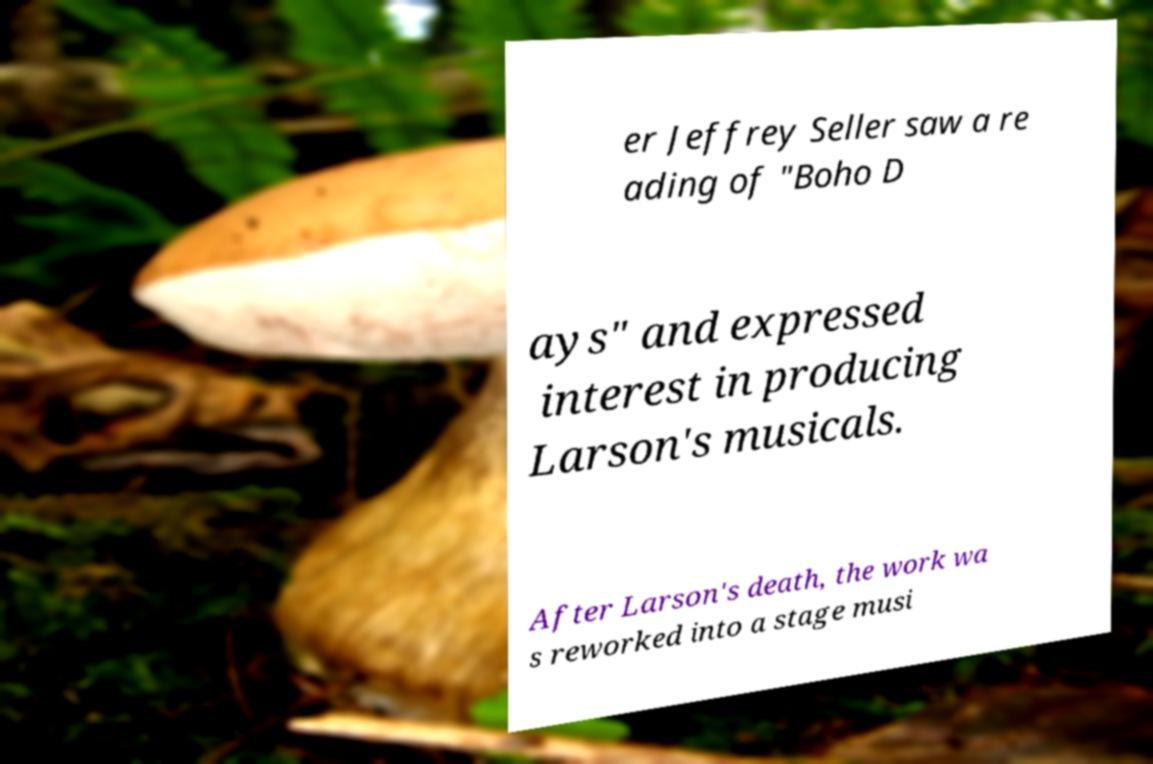There's text embedded in this image that I need extracted. Can you transcribe it verbatim? er Jeffrey Seller saw a re ading of "Boho D ays" and expressed interest in producing Larson's musicals. After Larson's death, the work wa s reworked into a stage musi 